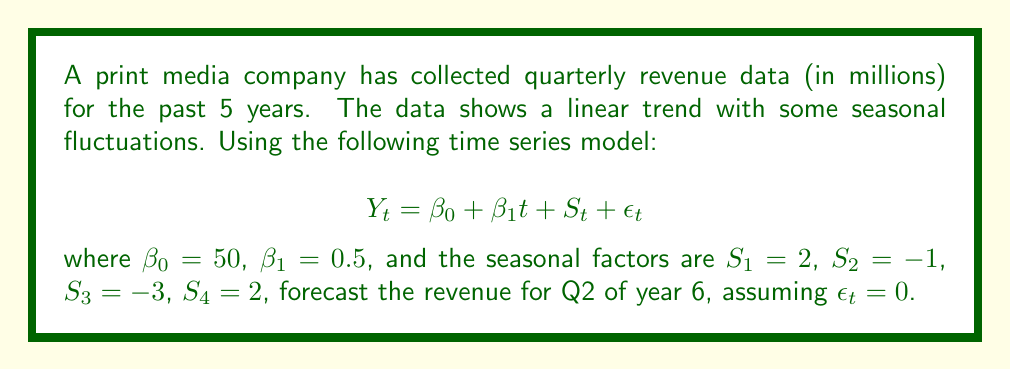Show me your answer to this math problem. To forecast the revenue for Q2 of year 6, we need to follow these steps:

1. Determine the time index $t$ for Q2 of year 6:
   - Each year has 4 quarters, so 5 years = 20 quarters
   - Q2 of year 6 would be the 22nd data point
   - Therefore, $t = 22$

2. Identify the seasonal factor for Q2:
   - Q2 corresponds to $S_2 = -1$

3. Apply the time series model:
   $$Y_t = \beta_0 + \beta_1t + S_t + \epsilon_t$$

   Substituting the given values:
   $$Y_{22} = 50 + 0.5(22) + (-1) + 0$$

4. Calculate the forecast:
   $$Y_{22} = 50 + 11 - 1 = 60$$

Therefore, the forecasted revenue for Q2 of year 6 is $60 million.
Answer: $60 million 